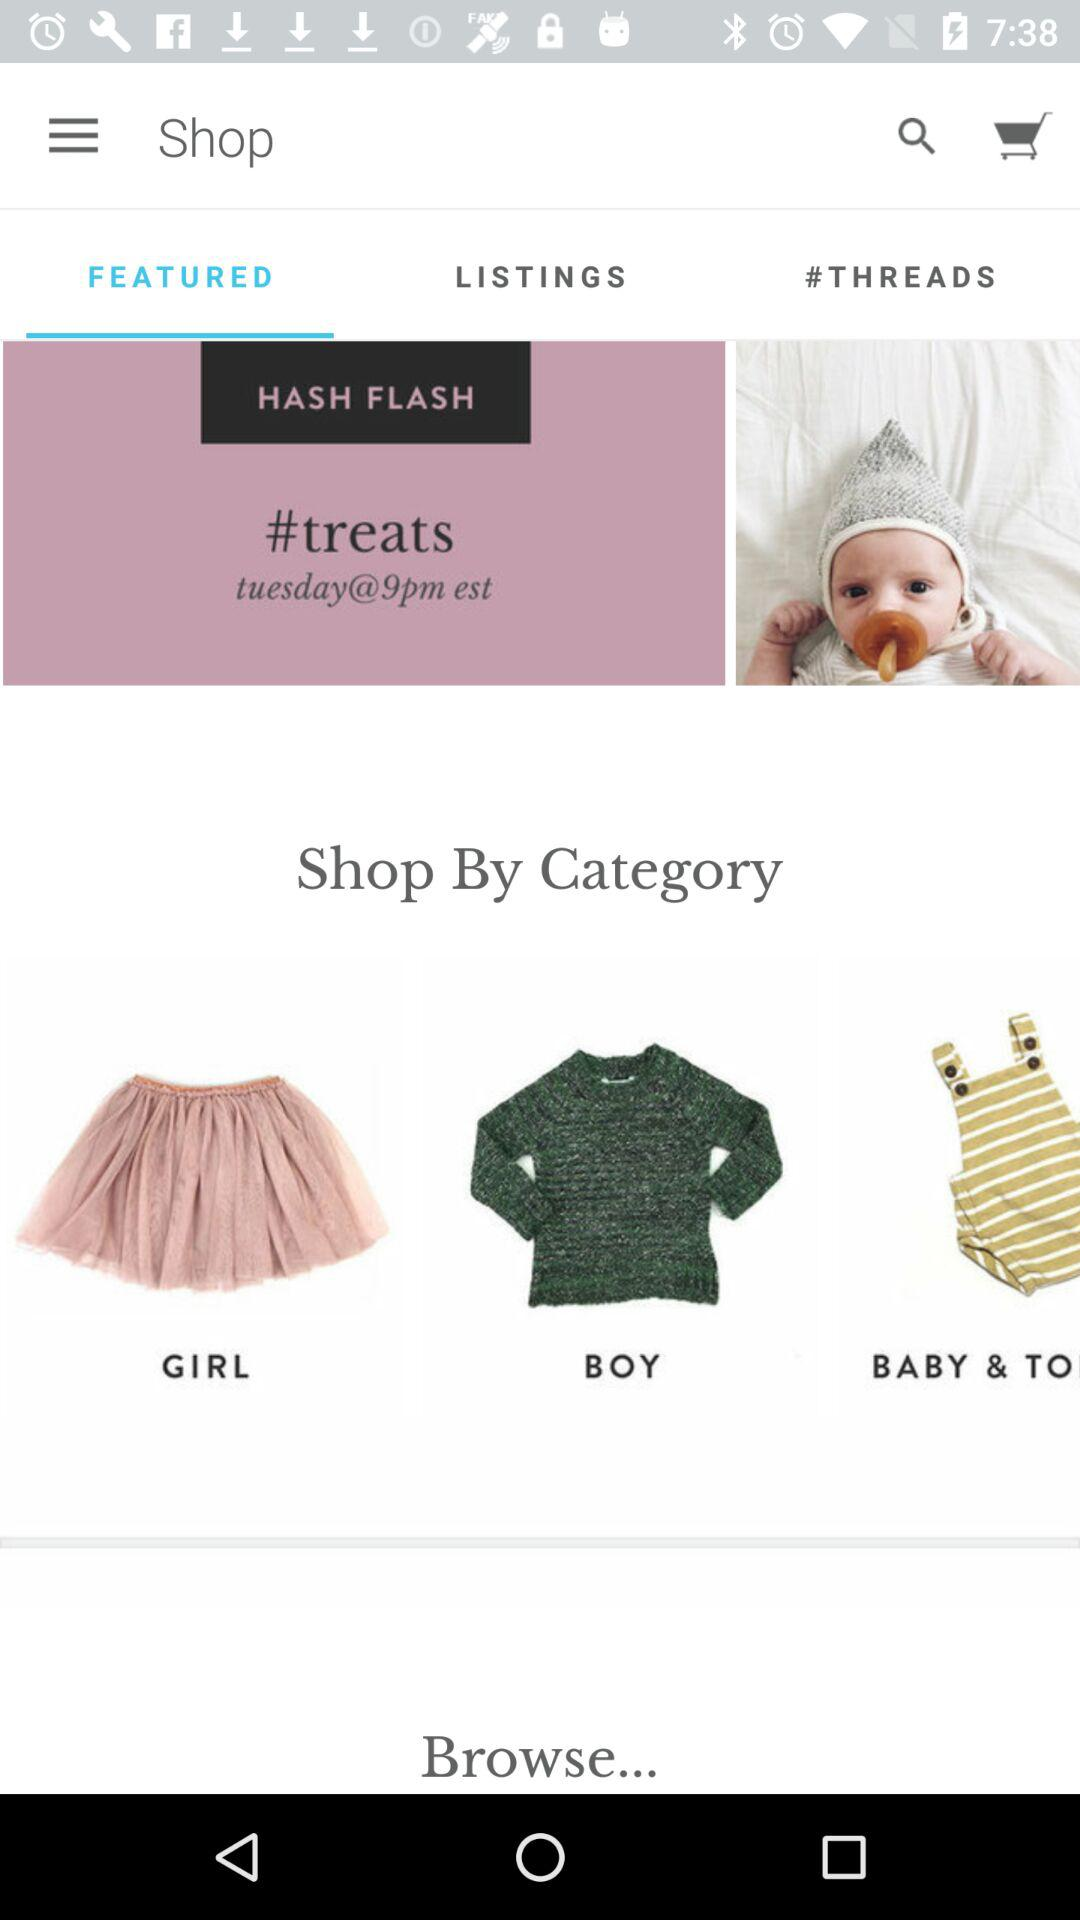What is the application name? The application name is "Shop". 